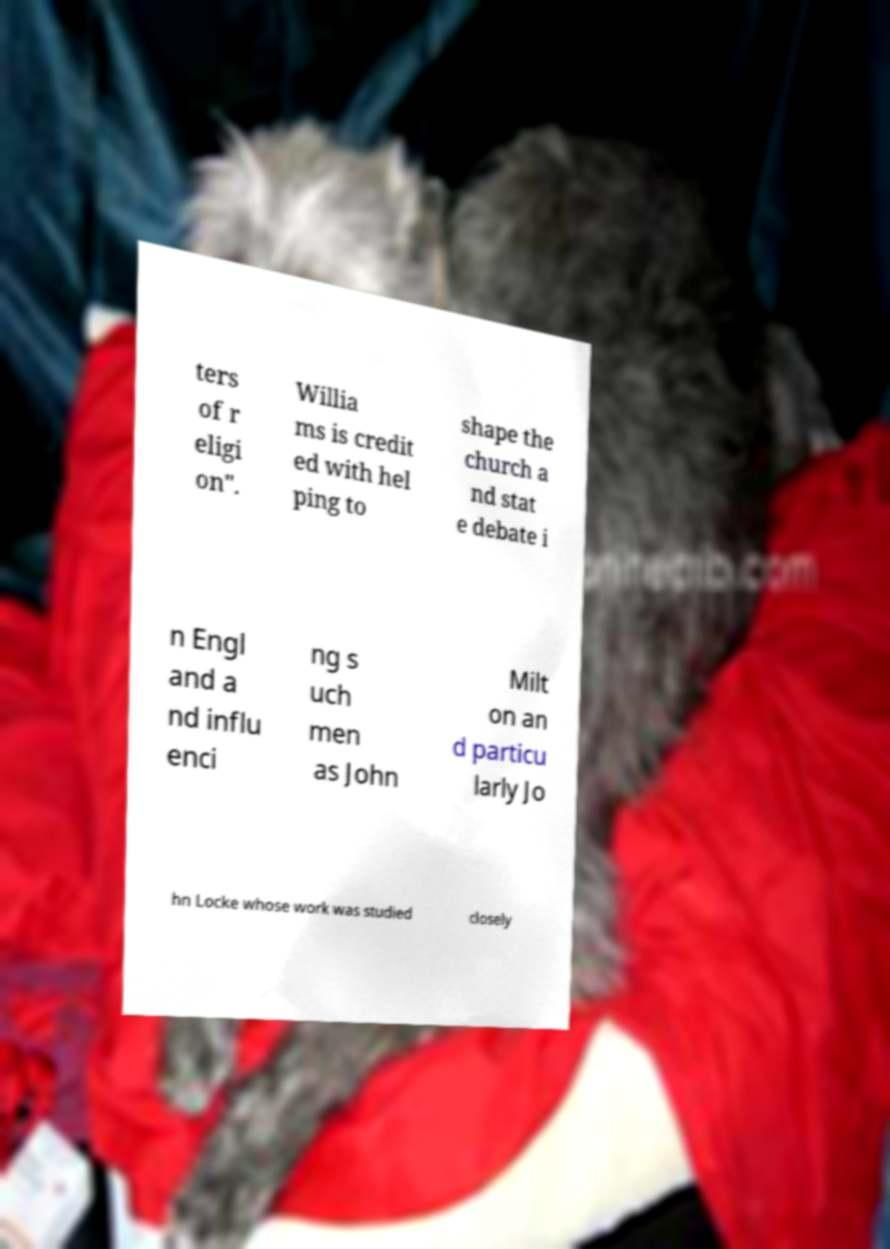Can you read and provide the text displayed in the image?This photo seems to have some interesting text. Can you extract and type it out for me? ters of r eligi on". Willia ms is credit ed with hel ping to shape the church a nd stat e debate i n Engl and a nd influ enci ng s uch men as John Milt on an d particu larly Jo hn Locke whose work was studied closely 